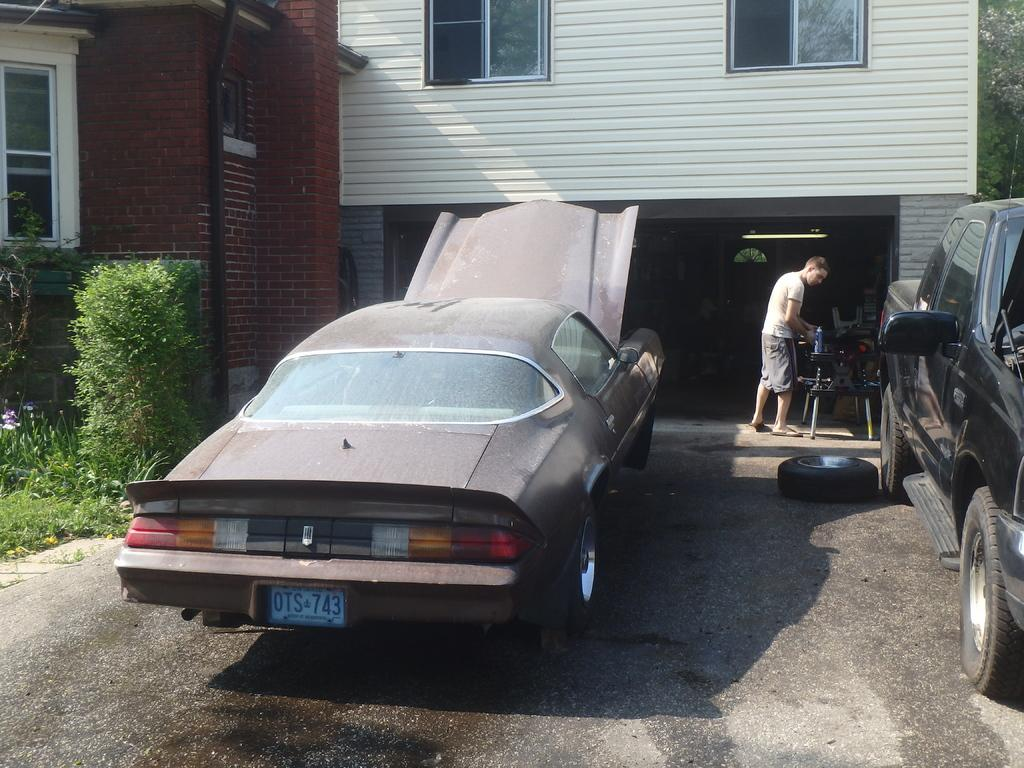What can be seen in the image? There are vehicles in the image. What is on the ground in the image? There is a tyre on the ground in the image. Can you describe the background of the image? There is a person, a building, trees, and some objects in the background of the image. How many hands does the tyre have in the image? The tyre does not have hands, as it is an inanimate object. 